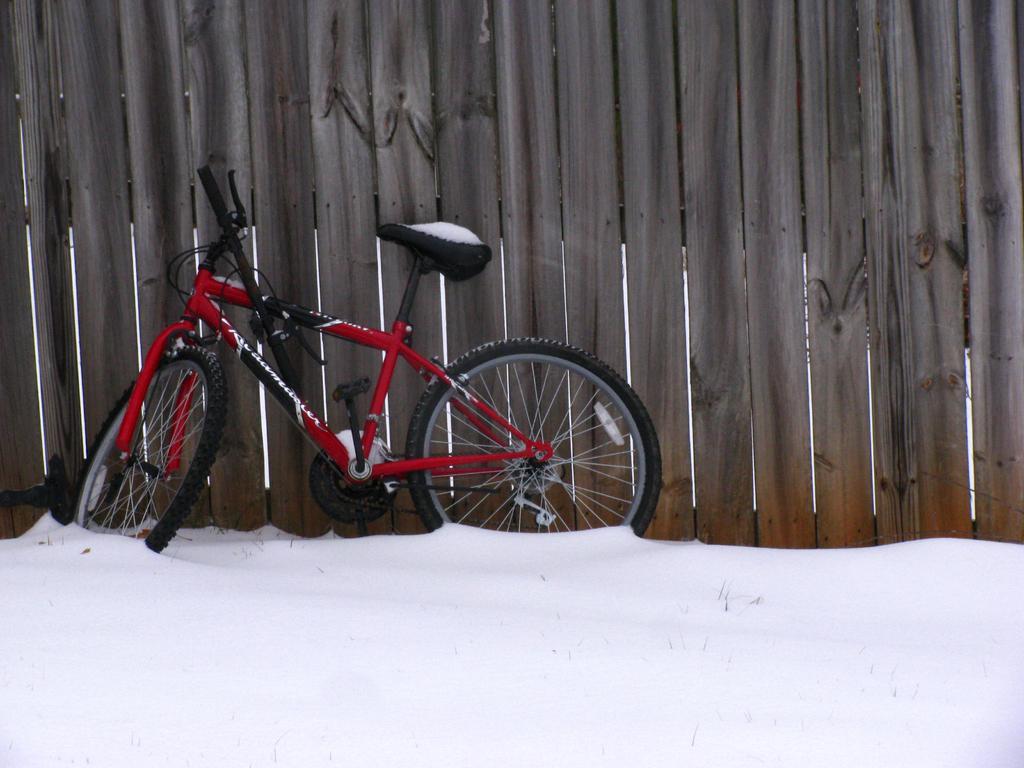Please provide a concise description of this image. In this image there is a cycle leaning into the wooden fence on the surface of the snow. 